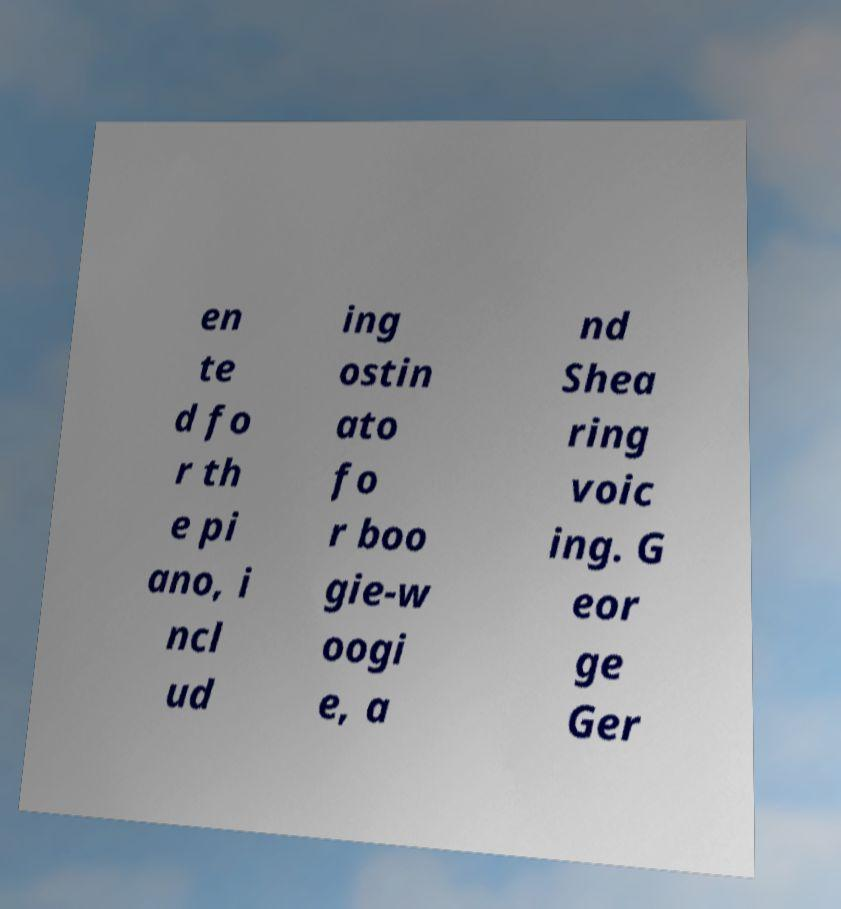What messages or text are displayed in this image? I need them in a readable, typed format. en te d fo r th e pi ano, i ncl ud ing ostin ato fo r boo gie-w oogi e, a nd Shea ring voic ing. G eor ge Ger 